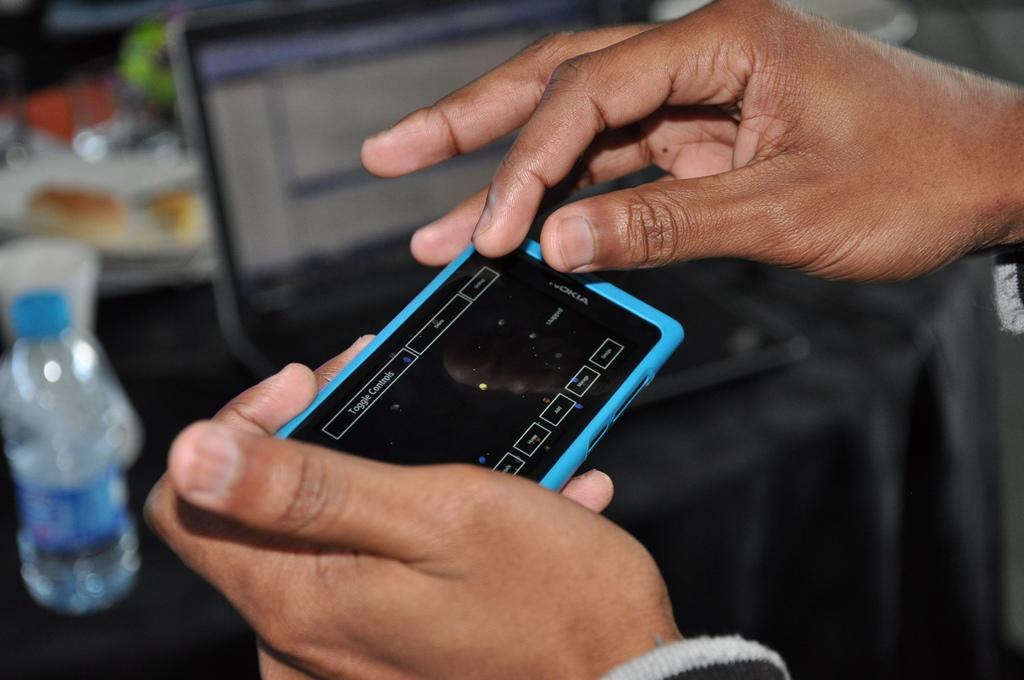<image>
Summarize the visual content of the image. a phone with the term toggle controls at the top 